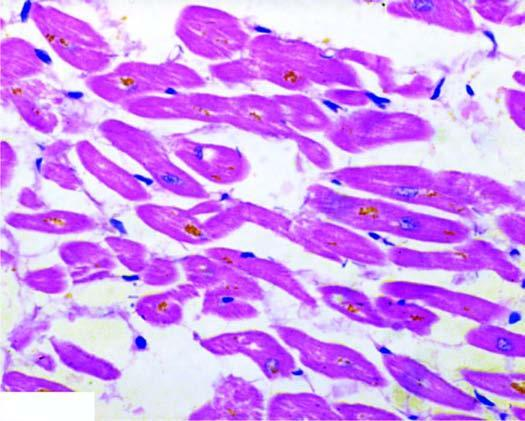what are seen in the cytoplasm of the myocardial fibres, especially around the nuclei?
Answer the question using a single word or phrase. Lipofuscin pigment granules nuclei 